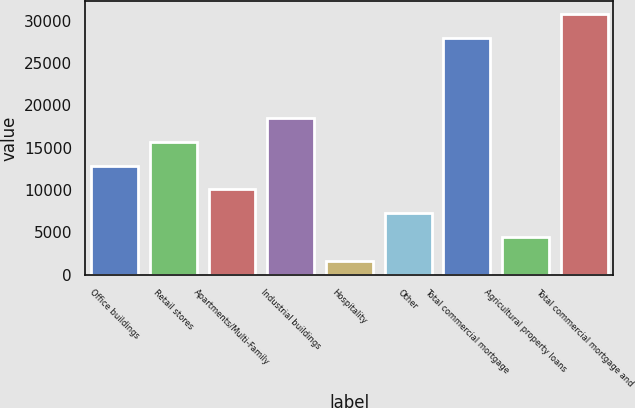<chart> <loc_0><loc_0><loc_500><loc_500><bar_chart><fcel>Office buildings<fcel>Retail stores<fcel>Apartments/Multi-Family<fcel>Industrial buildings<fcel>Hospitality<fcel>Other<fcel>Total commercial mortgage<fcel>Agricultural property loans<fcel>Total commercial mortgage and<nl><fcel>12880<fcel>15704<fcel>10056<fcel>18528<fcel>1584<fcel>7232<fcel>27931<fcel>4408<fcel>30755<nl></chart> 